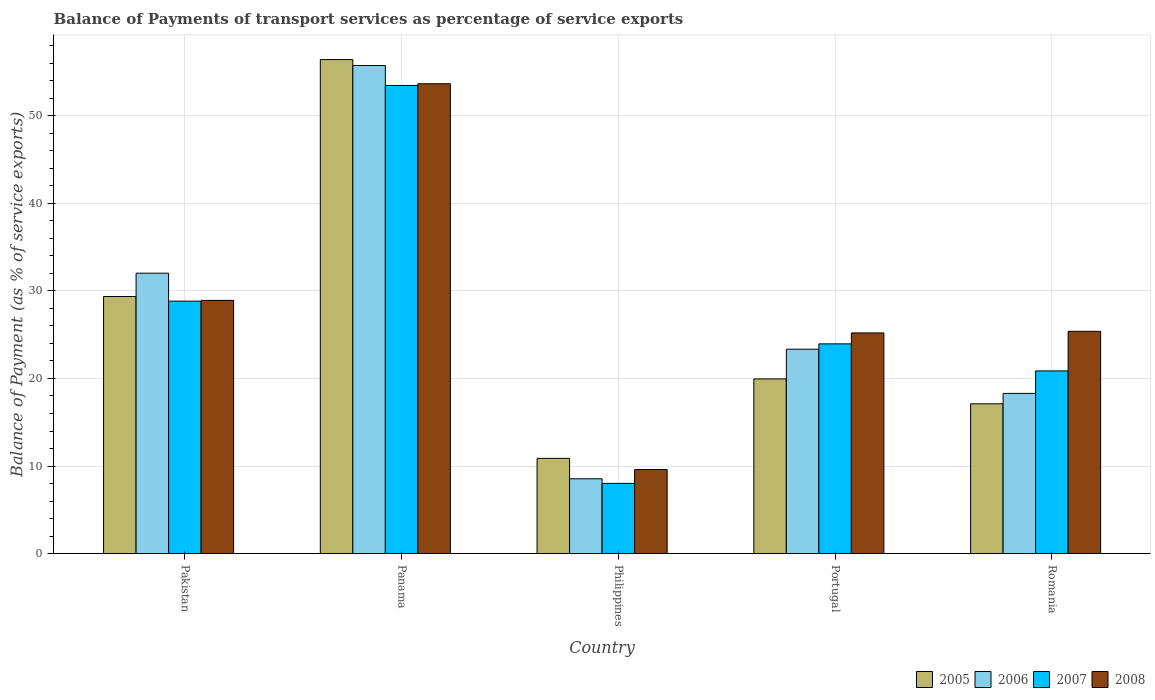How many different coloured bars are there?
Your answer should be very brief. 4. How many groups of bars are there?
Offer a very short reply. 5. Are the number of bars per tick equal to the number of legend labels?
Offer a terse response. Yes. Are the number of bars on each tick of the X-axis equal?
Make the answer very short. Yes. How many bars are there on the 3rd tick from the right?
Ensure brevity in your answer.  4. What is the label of the 4th group of bars from the left?
Provide a short and direct response. Portugal. In how many cases, is the number of bars for a given country not equal to the number of legend labels?
Your answer should be compact. 0. What is the balance of payments of transport services in 2006 in Romania?
Offer a terse response. 18.3. Across all countries, what is the maximum balance of payments of transport services in 2005?
Provide a short and direct response. 56.41. Across all countries, what is the minimum balance of payments of transport services in 2005?
Provide a succinct answer. 10.88. In which country was the balance of payments of transport services in 2007 maximum?
Ensure brevity in your answer.  Panama. What is the total balance of payments of transport services in 2008 in the graph?
Provide a short and direct response. 142.75. What is the difference between the balance of payments of transport services in 2007 in Philippines and that in Portugal?
Make the answer very short. -15.93. What is the difference between the balance of payments of transport services in 2006 in Portugal and the balance of payments of transport services in 2007 in Philippines?
Your answer should be very brief. 15.32. What is the average balance of payments of transport services in 2006 per country?
Your answer should be very brief. 27.59. What is the difference between the balance of payments of transport services of/in 2006 and balance of payments of transport services of/in 2007 in Romania?
Give a very brief answer. -2.57. In how many countries, is the balance of payments of transport services in 2006 greater than 56 %?
Provide a short and direct response. 0. What is the ratio of the balance of payments of transport services in 2005 in Pakistan to that in Romania?
Keep it short and to the point. 1.72. Is the balance of payments of transport services in 2005 in Pakistan less than that in Philippines?
Your answer should be compact. No. What is the difference between the highest and the second highest balance of payments of transport services in 2007?
Your response must be concise. -24.62. What is the difference between the highest and the lowest balance of payments of transport services in 2005?
Your response must be concise. 45.53. Is the sum of the balance of payments of transport services in 2005 in Pakistan and Philippines greater than the maximum balance of payments of transport services in 2007 across all countries?
Give a very brief answer. No. What does the 2nd bar from the left in Panama represents?
Keep it short and to the point. 2006. What does the 1st bar from the right in Philippines represents?
Provide a succinct answer. 2008. How many bars are there?
Make the answer very short. 20. How many countries are there in the graph?
Keep it short and to the point. 5. What is the difference between two consecutive major ticks on the Y-axis?
Your answer should be compact. 10. Are the values on the major ticks of Y-axis written in scientific E-notation?
Provide a short and direct response. No. Does the graph contain any zero values?
Give a very brief answer. No. Does the graph contain grids?
Give a very brief answer. Yes. How are the legend labels stacked?
Your answer should be compact. Horizontal. What is the title of the graph?
Offer a terse response. Balance of Payments of transport services as percentage of service exports. Does "1973" appear as one of the legend labels in the graph?
Your answer should be very brief. No. What is the label or title of the X-axis?
Provide a short and direct response. Country. What is the label or title of the Y-axis?
Provide a succinct answer. Balance of Payment (as % of service exports). What is the Balance of Payment (as % of service exports) of 2005 in Pakistan?
Make the answer very short. 29.36. What is the Balance of Payment (as % of service exports) of 2006 in Pakistan?
Your answer should be compact. 32.02. What is the Balance of Payment (as % of service exports) of 2007 in Pakistan?
Make the answer very short. 28.83. What is the Balance of Payment (as % of service exports) in 2008 in Pakistan?
Your answer should be very brief. 28.91. What is the Balance of Payment (as % of service exports) of 2005 in Panama?
Provide a succinct answer. 56.41. What is the Balance of Payment (as % of service exports) of 2006 in Panama?
Give a very brief answer. 55.73. What is the Balance of Payment (as % of service exports) in 2007 in Panama?
Ensure brevity in your answer.  53.45. What is the Balance of Payment (as % of service exports) of 2008 in Panama?
Provide a short and direct response. 53.65. What is the Balance of Payment (as % of service exports) of 2005 in Philippines?
Make the answer very short. 10.88. What is the Balance of Payment (as % of service exports) in 2006 in Philippines?
Keep it short and to the point. 8.55. What is the Balance of Payment (as % of service exports) in 2007 in Philippines?
Provide a short and direct response. 8.02. What is the Balance of Payment (as % of service exports) in 2008 in Philippines?
Ensure brevity in your answer.  9.61. What is the Balance of Payment (as % of service exports) in 2005 in Portugal?
Make the answer very short. 19.95. What is the Balance of Payment (as % of service exports) in 2006 in Portugal?
Ensure brevity in your answer.  23.34. What is the Balance of Payment (as % of service exports) of 2007 in Portugal?
Give a very brief answer. 23.95. What is the Balance of Payment (as % of service exports) of 2008 in Portugal?
Give a very brief answer. 25.2. What is the Balance of Payment (as % of service exports) in 2005 in Romania?
Your answer should be very brief. 17.11. What is the Balance of Payment (as % of service exports) in 2006 in Romania?
Offer a very short reply. 18.3. What is the Balance of Payment (as % of service exports) of 2007 in Romania?
Provide a succinct answer. 20.86. What is the Balance of Payment (as % of service exports) of 2008 in Romania?
Your response must be concise. 25.38. Across all countries, what is the maximum Balance of Payment (as % of service exports) of 2005?
Provide a succinct answer. 56.41. Across all countries, what is the maximum Balance of Payment (as % of service exports) in 2006?
Offer a terse response. 55.73. Across all countries, what is the maximum Balance of Payment (as % of service exports) in 2007?
Your answer should be very brief. 53.45. Across all countries, what is the maximum Balance of Payment (as % of service exports) in 2008?
Keep it short and to the point. 53.65. Across all countries, what is the minimum Balance of Payment (as % of service exports) in 2005?
Provide a succinct answer. 10.88. Across all countries, what is the minimum Balance of Payment (as % of service exports) of 2006?
Offer a terse response. 8.55. Across all countries, what is the minimum Balance of Payment (as % of service exports) in 2007?
Offer a terse response. 8.02. Across all countries, what is the minimum Balance of Payment (as % of service exports) in 2008?
Your response must be concise. 9.61. What is the total Balance of Payment (as % of service exports) in 2005 in the graph?
Keep it short and to the point. 133.7. What is the total Balance of Payment (as % of service exports) in 2006 in the graph?
Provide a short and direct response. 137.94. What is the total Balance of Payment (as % of service exports) in 2007 in the graph?
Offer a terse response. 135.12. What is the total Balance of Payment (as % of service exports) in 2008 in the graph?
Your answer should be compact. 142.75. What is the difference between the Balance of Payment (as % of service exports) in 2005 in Pakistan and that in Panama?
Your response must be concise. -27.05. What is the difference between the Balance of Payment (as % of service exports) of 2006 in Pakistan and that in Panama?
Provide a short and direct response. -23.71. What is the difference between the Balance of Payment (as % of service exports) in 2007 in Pakistan and that in Panama?
Your answer should be compact. -24.62. What is the difference between the Balance of Payment (as % of service exports) of 2008 in Pakistan and that in Panama?
Provide a short and direct response. -24.73. What is the difference between the Balance of Payment (as % of service exports) of 2005 in Pakistan and that in Philippines?
Keep it short and to the point. 18.48. What is the difference between the Balance of Payment (as % of service exports) of 2006 in Pakistan and that in Philippines?
Give a very brief answer. 23.47. What is the difference between the Balance of Payment (as % of service exports) of 2007 in Pakistan and that in Philippines?
Your response must be concise. 20.81. What is the difference between the Balance of Payment (as % of service exports) of 2008 in Pakistan and that in Philippines?
Your answer should be very brief. 19.31. What is the difference between the Balance of Payment (as % of service exports) of 2005 in Pakistan and that in Portugal?
Provide a succinct answer. 9.41. What is the difference between the Balance of Payment (as % of service exports) of 2006 in Pakistan and that in Portugal?
Your response must be concise. 8.68. What is the difference between the Balance of Payment (as % of service exports) in 2007 in Pakistan and that in Portugal?
Your answer should be very brief. 4.88. What is the difference between the Balance of Payment (as % of service exports) in 2008 in Pakistan and that in Portugal?
Keep it short and to the point. 3.71. What is the difference between the Balance of Payment (as % of service exports) in 2005 in Pakistan and that in Romania?
Provide a short and direct response. 12.25. What is the difference between the Balance of Payment (as % of service exports) of 2006 in Pakistan and that in Romania?
Provide a short and direct response. 13.72. What is the difference between the Balance of Payment (as % of service exports) of 2007 in Pakistan and that in Romania?
Your response must be concise. 7.97. What is the difference between the Balance of Payment (as % of service exports) in 2008 in Pakistan and that in Romania?
Give a very brief answer. 3.53. What is the difference between the Balance of Payment (as % of service exports) of 2005 in Panama and that in Philippines?
Offer a terse response. 45.53. What is the difference between the Balance of Payment (as % of service exports) in 2006 in Panama and that in Philippines?
Give a very brief answer. 47.19. What is the difference between the Balance of Payment (as % of service exports) of 2007 in Panama and that in Philippines?
Provide a short and direct response. 45.43. What is the difference between the Balance of Payment (as % of service exports) in 2008 in Panama and that in Philippines?
Offer a very short reply. 44.04. What is the difference between the Balance of Payment (as % of service exports) of 2005 in Panama and that in Portugal?
Provide a short and direct response. 36.46. What is the difference between the Balance of Payment (as % of service exports) in 2006 in Panama and that in Portugal?
Your response must be concise. 32.39. What is the difference between the Balance of Payment (as % of service exports) in 2007 in Panama and that in Portugal?
Your response must be concise. 29.5. What is the difference between the Balance of Payment (as % of service exports) in 2008 in Panama and that in Portugal?
Your answer should be very brief. 28.45. What is the difference between the Balance of Payment (as % of service exports) of 2005 in Panama and that in Romania?
Offer a terse response. 39.3. What is the difference between the Balance of Payment (as % of service exports) of 2006 in Panama and that in Romania?
Give a very brief answer. 37.44. What is the difference between the Balance of Payment (as % of service exports) in 2007 in Panama and that in Romania?
Offer a very short reply. 32.59. What is the difference between the Balance of Payment (as % of service exports) of 2008 in Panama and that in Romania?
Keep it short and to the point. 28.26. What is the difference between the Balance of Payment (as % of service exports) of 2005 in Philippines and that in Portugal?
Your answer should be very brief. -9.07. What is the difference between the Balance of Payment (as % of service exports) of 2006 in Philippines and that in Portugal?
Provide a succinct answer. -14.8. What is the difference between the Balance of Payment (as % of service exports) in 2007 in Philippines and that in Portugal?
Your answer should be very brief. -15.93. What is the difference between the Balance of Payment (as % of service exports) in 2008 in Philippines and that in Portugal?
Your answer should be very brief. -15.59. What is the difference between the Balance of Payment (as % of service exports) of 2005 in Philippines and that in Romania?
Give a very brief answer. -6.23. What is the difference between the Balance of Payment (as % of service exports) of 2006 in Philippines and that in Romania?
Give a very brief answer. -9.75. What is the difference between the Balance of Payment (as % of service exports) of 2007 in Philippines and that in Romania?
Give a very brief answer. -12.84. What is the difference between the Balance of Payment (as % of service exports) in 2008 in Philippines and that in Romania?
Offer a terse response. -15.77. What is the difference between the Balance of Payment (as % of service exports) of 2005 in Portugal and that in Romania?
Give a very brief answer. 2.84. What is the difference between the Balance of Payment (as % of service exports) of 2006 in Portugal and that in Romania?
Your answer should be very brief. 5.05. What is the difference between the Balance of Payment (as % of service exports) of 2007 in Portugal and that in Romania?
Provide a short and direct response. 3.09. What is the difference between the Balance of Payment (as % of service exports) in 2008 in Portugal and that in Romania?
Keep it short and to the point. -0.18. What is the difference between the Balance of Payment (as % of service exports) in 2005 in Pakistan and the Balance of Payment (as % of service exports) in 2006 in Panama?
Keep it short and to the point. -26.37. What is the difference between the Balance of Payment (as % of service exports) in 2005 in Pakistan and the Balance of Payment (as % of service exports) in 2007 in Panama?
Your answer should be very brief. -24.09. What is the difference between the Balance of Payment (as % of service exports) of 2005 in Pakistan and the Balance of Payment (as % of service exports) of 2008 in Panama?
Your answer should be very brief. -24.29. What is the difference between the Balance of Payment (as % of service exports) of 2006 in Pakistan and the Balance of Payment (as % of service exports) of 2007 in Panama?
Keep it short and to the point. -21.43. What is the difference between the Balance of Payment (as % of service exports) of 2006 in Pakistan and the Balance of Payment (as % of service exports) of 2008 in Panama?
Your answer should be very brief. -21.63. What is the difference between the Balance of Payment (as % of service exports) in 2007 in Pakistan and the Balance of Payment (as % of service exports) in 2008 in Panama?
Give a very brief answer. -24.82. What is the difference between the Balance of Payment (as % of service exports) of 2005 in Pakistan and the Balance of Payment (as % of service exports) of 2006 in Philippines?
Offer a very short reply. 20.81. What is the difference between the Balance of Payment (as % of service exports) of 2005 in Pakistan and the Balance of Payment (as % of service exports) of 2007 in Philippines?
Give a very brief answer. 21.33. What is the difference between the Balance of Payment (as % of service exports) in 2005 in Pakistan and the Balance of Payment (as % of service exports) in 2008 in Philippines?
Offer a very short reply. 19.75. What is the difference between the Balance of Payment (as % of service exports) in 2006 in Pakistan and the Balance of Payment (as % of service exports) in 2007 in Philippines?
Your answer should be very brief. 24. What is the difference between the Balance of Payment (as % of service exports) of 2006 in Pakistan and the Balance of Payment (as % of service exports) of 2008 in Philippines?
Your answer should be compact. 22.41. What is the difference between the Balance of Payment (as % of service exports) in 2007 in Pakistan and the Balance of Payment (as % of service exports) in 2008 in Philippines?
Ensure brevity in your answer.  19.22. What is the difference between the Balance of Payment (as % of service exports) of 2005 in Pakistan and the Balance of Payment (as % of service exports) of 2006 in Portugal?
Keep it short and to the point. 6.02. What is the difference between the Balance of Payment (as % of service exports) in 2005 in Pakistan and the Balance of Payment (as % of service exports) in 2007 in Portugal?
Provide a short and direct response. 5.41. What is the difference between the Balance of Payment (as % of service exports) of 2005 in Pakistan and the Balance of Payment (as % of service exports) of 2008 in Portugal?
Your response must be concise. 4.16. What is the difference between the Balance of Payment (as % of service exports) in 2006 in Pakistan and the Balance of Payment (as % of service exports) in 2007 in Portugal?
Ensure brevity in your answer.  8.07. What is the difference between the Balance of Payment (as % of service exports) in 2006 in Pakistan and the Balance of Payment (as % of service exports) in 2008 in Portugal?
Ensure brevity in your answer.  6.82. What is the difference between the Balance of Payment (as % of service exports) of 2007 in Pakistan and the Balance of Payment (as % of service exports) of 2008 in Portugal?
Provide a short and direct response. 3.63. What is the difference between the Balance of Payment (as % of service exports) in 2005 in Pakistan and the Balance of Payment (as % of service exports) in 2006 in Romania?
Make the answer very short. 11.06. What is the difference between the Balance of Payment (as % of service exports) in 2005 in Pakistan and the Balance of Payment (as % of service exports) in 2007 in Romania?
Make the answer very short. 8.5. What is the difference between the Balance of Payment (as % of service exports) of 2005 in Pakistan and the Balance of Payment (as % of service exports) of 2008 in Romania?
Your response must be concise. 3.98. What is the difference between the Balance of Payment (as % of service exports) of 2006 in Pakistan and the Balance of Payment (as % of service exports) of 2007 in Romania?
Provide a succinct answer. 11.16. What is the difference between the Balance of Payment (as % of service exports) of 2006 in Pakistan and the Balance of Payment (as % of service exports) of 2008 in Romania?
Ensure brevity in your answer.  6.64. What is the difference between the Balance of Payment (as % of service exports) of 2007 in Pakistan and the Balance of Payment (as % of service exports) of 2008 in Romania?
Give a very brief answer. 3.45. What is the difference between the Balance of Payment (as % of service exports) in 2005 in Panama and the Balance of Payment (as % of service exports) in 2006 in Philippines?
Offer a very short reply. 47.86. What is the difference between the Balance of Payment (as % of service exports) in 2005 in Panama and the Balance of Payment (as % of service exports) in 2007 in Philippines?
Provide a short and direct response. 48.38. What is the difference between the Balance of Payment (as % of service exports) of 2005 in Panama and the Balance of Payment (as % of service exports) of 2008 in Philippines?
Your response must be concise. 46.8. What is the difference between the Balance of Payment (as % of service exports) in 2006 in Panama and the Balance of Payment (as % of service exports) in 2007 in Philippines?
Keep it short and to the point. 47.71. What is the difference between the Balance of Payment (as % of service exports) of 2006 in Panama and the Balance of Payment (as % of service exports) of 2008 in Philippines?
Ensure brevity in your answer.  46.12. What is the difference between the Balance of Payment (as % of service exports) in 2007 in Panama and the Balance of Payment (as % of service exports) in 2008 in Philippines?
Provide a succinct answer. 43.84. What is the difference between the Balance of Payment (as % of service exports) of 2005 in Panama and the Balance of Payment (as % of service exports) of 2006 in Portugal?
Provide a short and direct response. 33.06. What is the difference between the Balance of Payment (as % of service exports) of 2005 in Panama and the Balance of Payment (as % of service exports) of 2007 in Portugal?
Offer a terse response. 32.46. What is the difference between the Balance of Payment (as % of service exports) in 2005 in Panama and the Balance of Payment (as % of service exports) in 2008 in Portugal?
Give a very brief answer. 31.21. What is the difference between the Balance of Payment (as % of service exports) of 2006 in Panama and the Balance of Payment (as % of service exports) of 2007 in Portugal?
Give a very brief answer. 31.78. What is the difference between the Balance of Payment (as % of service exports) in 2006 in Panama and the Balance of Payment (as % of service exports) in 2008 in Portugal?
Ensure brevity in your answer.  30.53. What is the difference between the Balance of Payment (as % of service exports) of 2007 in Panama and the Balance of Payment (as % of service exports) of 2008 in Portugal?
Offer a terse response. 28.25. What is the difference between the Balance of Payment (as % of service exports) in 2005 in Panama and the Balance of Payment (as % of service exports) in 2006 in Romania?
Provide a short and direct response. 38.11. What is the difference between the Balance of Payment (as % of service exports) in 2005 in Panama and the Balance of Payment (as % of service exports) in 2007 in Romania?
Offer a very short reply. 35.54. What is the difference between the Balance of Payment (as % of service exports) in 2005 in Panama and the Balance of Payment (as % of service exports) in 2008 in Romania?
Provide a short and direct response. 31.02. What is the difference between the Balance of Payment (as % of service exports) of 2006 in Panama and the Balance of Payment (as % of service exports) of 2007 in Romania?
Give a very brief answer. 34.87. What is the difference between the Balance of Payment (as % of service exports) in 2006 in Panama and the Balance of Payment (as % of service exports) in 2008 in Romania?
Ensure brevity in your answer.  30.35. What is the difference between the Balance of Payment (as % of service exports) in 2007 in Panama and the Balance of Payment (as % of service exports) in 2008 in Romania?
Ensure brevity in your answer.  28.07. What is the difference between the Balance of Payment (as % of service exports) in 2005 in Philippines and the Balance of Payment (as % of service exports) in 2006 in Portugal?
Your answer should be compact. -12.46. What is the difference between the Balance of Payment (as % of service exports) of 2005 in Philippines and the Balance of Payment (as % of service exports) of 2007 in Portugal?
Offer a very short reply. -13.07. What is the difference between the Balance of Payment (as % of service exports) of 2005 in Philippines and the Balance of Payment (as % of service exports) of 2008 in Portugal?
Keep it short and to the point. -14.32. What is the difference between the Balance of Payment (as % of service exports) in 2006 in Philippines and the Balance of Payment (as % of service exports) in 2007 in Portugal?
Your answer should be very brief. -15.4. What is the difference between the Balance of Payment (as % of service exports) in 2006 in Philippines and the Balance of Payment (as % of service exports) in 2008 in Portugal?
Your response must be concise. -16.65. What is the difference between the Balance of Payment (as % of service exports) of 2007 in Philippines and the Balance of Payment (as % of service exports) of 2008 in Portugal?
Make the answer very short. -17.18. What is the difference between the Balance of Payment (as % of service exports) in 2005 in Philippines and the Balance of Payment (as % of service exports) in 2006 in Romania?
Ensure brevity in your answer.  -7.42. What is the difference between the Balance of Payment (as % of service exports) of 2005 in Philippines and the Balance of Payment (as % of service exports) of 2007 in Romania?
Keep it short and to the point. -9.98. What is the difference between the Balance of Payment (as % of service exports) in 2005 in Philippines and the Balance of Payment (as % of service exports) in 2008 in Romania?
Offer a terse response. -14.5. What is the difference between the Balance of Payment (as % of service exports) in 2006 in Philippines and the Balance of Payment (as % of service exports) in 2007 in Romania?
Offer a terse response. -12.32. What is the difference between the Balance of Payment (as % of service exports) of 2006 in Philippines and the Balance of Payment (as % of service exports) of 2008 in Romania?
Provide a short and direct response. -16.84. What is the difference between the Balance of Payment (as % of service exports) of 2007 in Philippines and the Balance of Payment (as % of service exports) of 2008 in Romania?
Your response must be concise. -17.36. What is the difference between the Balance of Payment (as % of service exports) of 2005 in Portugal and the Balance of Payment (as % of service exports) of 2006 in Romania?
Keep it short and to the point. 1.65. What is the difference between the Balance of Payment (as % of service exports) in 2005 in Portugal and the Balance of Payment (as % of service exports) in 2007 in Romania?
Make the answer very short. -0.91. What is the difference between the Balance of Payment (as % of service exports) in 2005 in Portugal and the Balance of Payment (as % of service exports) in 2008 in Romania?
Your response must be concise. -5.43. What is the difference between the Balance of Payment (as % of service exports) in 2006 in Portugal and the Balance of Payment (as % of service exports) in 2007 in Romania?
Your answer should be very brief. 2.48. What is the difference between the Balance of Payment (as % of service exports) in 2006 in Portugal and the Balance of Payment (as % of service exports) in 2008 in Romania?
Keep it short and to the point. -2.04. What is the difference between the Balance of Payment (as % of service exports) in 2007 in Portugal and the Balance of Payment (as % of service exports) in 2008 in Romania?
Your answer should be compact. -1.43. What is the average Balance of Payment (as % of service exports) of 2005 per country?
Keep it short and to the point. 26.74. What is the average Balance of Payment (as % of service exports) in 2006 per country?
Ensure brevity in your answer.  27.59. What is the average Balance of Payment (as % of service exports) of 2007 per country?
Your answer should be very brief. 27.02. What is the average Balance of Payment (as % of service exports) of 2008 per country?
Offer a very short reply. 28.55. What is the difference between the Balance of Payment (as % of service exports) of 2005 and Balance of Payment (as % of service exports) of 2006 in Pakistan?
Make the answer very short. -2.66. What is the difference between the Balance of Payment (as % of service exports) of 2005 and Balance of Payment (as % of service exports) of 2007 in Pakistan?
Provide a succinct answer. 0.53. What is the difference between the Balance of Payment (as % of service exports) of 2005 and Balance of Payment (as % of service exports) of 2008 in Pakistan?
Give a very brief answer. 0.44. What is the difference between the Balance of Payment (as % of service exports) in 2006 and Balance of Payment (as % of service exports) in 2007 in Pakistan?
Your answer should be compact. 3.19. What is the difference between the Balance of Payment (as % of service exports) of 2006 and Balance of Payment (as % of service exports) of 2008 in Pakistan?
Give a very brief answer. 3.1. What is the difference between the Balance of Payment (as % of service exports) of 2007 and Balance of Payment (as % of service exports) of 2008 in Pakistan?
Offer a terse response. -0.08. What is the difference between the Balance of Payment (as % of service exports) in 2005 and Balance of Payment (as % of service exports) in 2006 in Panama?
Give a very brief answer. 0.67. What is the difference between the Balance of Payment (as % of service exports) of 2005 and Balance of Payment (as % of service exports) of 2007 in Panama?
Offer a terse response. 2.95. What is the difference between the Balance of Payment (as % of service exports) of 2005 and Balance of Payment (as % of service exports) of 2008 in Panama?
Provide a short and direct response. 2.76. What is the difference between the Balance of Payment (as % of service exports) in 2006 and Balance of Payment (as % of service exports) in 2007 in Panama?
Your answer should be very brief. 2.28. What is the difference between the Balance of Payment (as % of service exports) of 2006 and Balance of Payment (as % of service exports) of 2008 in Panama?
Provide a succinct answer. 2.09. What is the difference between the Balance of Payment (as % of service exports) in 2007 and Balance of Payment (as % of service exports) in 2008 in Panama?
Offer a very short reply. -0.19. What is the difference between the Balance of Payment (as % of service exports) of 2005 and Balance of Payment (as % of service exports) of 2006 in Philippines?
Your answer should be very brief. 2.33. What is the difference between the Balance of Payment (as % of service exports) in 2005 and Balance of Payment (as % of service exports) in 2007 in Philippines?
Keep it short and to the point. 2.86. What is the difference between the Balance of Payment (as % of service exports) of 2005 and Balance of Payment (as % of service exports) of 2008 in Philippines?
Keep it short and to the point. 1.27. What is the difference between the Balance of Payment (as % of service exports) in 2006 and Balance of Payment (as % of service exports) in 2007 in Philippines?
Ensure brevity in your answer.  0.52. What is the difference between the Balance of Payment (as % of service exports) of 2006 and Balance of Payment (as % of service exports) of 2008 in Philippines?
Your response must be concise. -1.06. What is the difference between the Balance of Payment (as % of service exports) of 2007 and Balance of Payment (as % of service exports) of 2008 in Philippines?
Your answer should be very brief. -1.58. What is the difference between the Balance of Payment (as % of service exports) in 2005 and Balance of Payment (as % of service exports) in 2006 in Portugal?
Offer a very short reply. -3.4. What is the difference between the Balance of Payment (as % of service exports) of 2005 and Balance of Payment (as % of service exports) of 2007 in Portugal?
Make the answer very short. -4. What is the difference between the Balance of Payment (as % of service exports) of 2005 and Balance of Payment (as % of service exports) of 2008 in Portugal?
Keep it short and to the point. -5.25. What is the difference between the Balance of Payment (as % of service exports) in 2006 and Balance of Payment (as % of service exports) in 2007 in Portugal?
Make the answer very short. -0.61. What is the difference between the Balance of Payment (as % of service exports) of 2006 and Balance of Payment (as % of service exports) of 2008 in Portugal?
Your answer should be compact. -1.86. What is the difference between the Balance of Payment (as % of service exports) of 2007 and Balance of Payment (as % of service exports) of 2008 in Portugal?
Offer a very short reply. -1.25. What is the difference between the Balance of Payment (as % of service exports) of 2005 and Balance of Payment (as % of service exports) of 2006 in Romania?
Offer a terse response. -1.19. What is the difference between the Balance of Payment (as % of service exports) in 2005 and Balance of Payment (as % of service exports) in 2007 in Romania?
Offer a terse response. -3.76. What is the difference between the Balance of Payment (as % of service exports) of 2005 and Balance of Payment (as % of service exports) of 2008 in Romania?
Offer a very short reply. -8.28. What is the difference between the Balance of Payment (as % of service exports) in 2006 and Balance of Payment (as % of service exports) in 2007 in Romania?
Your answer should be very brief. -2.57. What is the difference between the Balance of Payment (as % of service exports) in 2006 and Balance of Payment (as % of service exports) in 2008 in Romania?
Keep it short and to the point. -7.09. What is the difference between the Balance of Payment (as % of service exports) in 2007 and Balance of Payment (as % of service exports) in 2008 in Romania?
Your answer should be compact. -4.52. What is the ratio of the Balance of Payment (as % of service exports) of 2005 in Pakistan to that in Panama?
Offer a very short reply. 0.52. What is the ratio of the Balance of Payment (as % of service exports) of 2006 in Pakistan to that in Panama?
Provide a short and direct response. 0.57. What is the ratio of the Balance of Payment (as % of service exports) of 2007 in Pakistan to that in Panama?
Your answer should be very brief. 0.54. What is the ratio of the Balance of Payment (as % of service exports) of 2008 in Pakistan to that in Panama?
Provide a short and direct response. 0.54. What is the ratio of the Balance of Payment (as % of service exports) in 2005 in Pakistan to that in Philippines?
Provide a short and direct response. 2.7. What is the ratio of the Balance of Payment (as % of service exports) in 2006 in Pakistan to that in Philippines?
Your response must be concise. 3.75. What is the ratio of the Balance of Payment (as % of service exports) of 2007 in Pakistan to that in Philippines?
Provide a succinct answer. 3.59. What is the ratio of the Balance of Payment (as % of service exports) in 2008 in Pakistan to that in Philippines?
Your response must be concise. 3.01. What is the ratio of the Balance of Payment (as % of service exports) of 2005 in Pakistan to that in Portugal?
Your answer should be very brief. 1.47. What is the ratio of the Balance of Payment (as % of service exports) in 2006 in Pakistan to that in Portugal?
Give a very brief answer. 1.37. What is the ratio of the Balance of Payment (as % of service exports) of 2007 in Pakistan to that in Portugal?
Your answer should be compact. 1.2. What is the ratio of the Balance of Payment (as % of service exports) in 2008 in Pakistan to that in Portugal?
Keep it short and to the point. 1.15. What is the ratio of the Balance of Payment (as % of service exports) of 2005 in Pakistan to that in Romania?
Your answer should be very brief. 1.72. What is the ratio of the Balance of Payment (as % of service exports) of 2006 in Pakistan to that in Romania?
Offer a very short reply. 1.75. What is the ratio of the Balance of Payment (as % of service exports) in 2007 in Pakistan to that in Romania?
Offer a very short reply. 1.38. What is the ratio of the Balance of Payment (as % of service exports) in 2008 in Pakistan to that in Romania?
Offer a terse response. 1.14. What is the ratio of the Balance of Payment (as % of service exports) of 2005 in Panama to that in Philippines?
Offer a terse response. 5.18. What is the ratio of the Balance of Payment (as % of service exports) of 2006 in Panama to that in Philippines?
Provide a succinct answer. 6.52. What is the ratio of the Balance of Payment (as % of service exports) of 2007 in Panama to that in Philippines?
Give a very brief answer. 6.66. What is the ratio of the Balance of Payment (as % of service exports) of 2008 in Panama to that in Philippines?
Your answer should be compact. 5.58. What is the ratio of the Balance of Payment (as % of service exports) of 2005 in Panama to that in Portugal?
Ensure brevity in your answer.  2.83. What is the ratio of the Balance of Payment (as % of service exports) in 2006 in Panama to that in Portugal?
Provide a short and direct response. 2.39. What is the ratio of the Balance of Payment (as % of service exports) in 2007 in Panama to that in Portugal?
Provide a short and direct response. 2.23. What is the ratio of the Balance of Payment (as % of service exports) in 2008 in Panama to that in Portugal?
Your response must be concise. 2.13. What is the ratio of the Balance of Payment (as % of service exports) of 2005 in Panama to that in Romania?
Your response must be concise. 3.3. What is the ratio of the Balance of Payment (as % of service exports) of 2006 in Panama to that in Romania?
Make the answer very short. 3.05. What is the ratio of the Balance of Payment (as % of service exports) of 2007 in Panama to that in Romania?
Ensure brevity in your answer.  2.56. What is the ratio of the Balance of Payment (as % of service exports) in 2008 in Panama to that in Romania?
Your response must be concise. 2.11. What is the ratio of the Balance of Payment (as % of service exports) of 2005 in Philippines to that in Portugal?
Your response must be concise. 0.55. What is the ratio of the Balance of Payment (as % of service exports) in 2006 in Philippines to that in Portugal?
Offer a terse response. 0.37. What is the ratio of the Balance of Payment (as % of service exports) of 2007 in Philippines to that in Portugal?
Your answer should be very brief. 0.34. What is the ratio of the Balance of Payment (as % of service exports) in 2008 in Philippines to that in Portugal?
Your response must be concise. 0.38. What is the ratio of the Balance of Payment (as % of service exports) of 2005 in Philippines to that in Romania?
Offer a terse response. 0.64. What is the ratio of the Balance of Payment (as % of service exports) of 2006 in Philippines to that in Romania?
Offer a very short reply. 0.47. What is the ratio of the Balance of Payment (as % of service exports) of 2007 in Philippines to that in Romania?
Offer a very short reply. 0.38. What is the ratio of the Balance of Payment (as % of service exports) in 2008 in Philippines to that in Romania?
Your answer should be compact. 0.38. What is the ratio of the Balance of Payment (as % of service exports) of 2005 in Portugal to that in Romania?
Ensure brevity in your answer.  1.17. What is the ratio of the Balance of Payment (as % of service exports) in 2006 in Portugal to that in Romania?
Make the answer very short. 1.28. What is the ratio of the Balance of Payment (as % of service exports) of 2007 in Portugal to that in Romania?
Make the answer very short. 1.15. What is the difference between the highest and the second highest Balance of Payment (as % of service exports) in 2005?
Your answer should be very brief. 27.05. What is the difference between the highest and the second highest Balance of Payment (as % of service exports) in 2006?
Your answer should be compact. 23.71. What is the difference between the highest and the second highest Balance of Payment (as % of service exports) in 2007?
Offer a very short reply. 24.62. What is the difference between the highest and the second highest Balance of Payment (as % of service exports) of 2008?
Offer a terse response. 24.73. What is the difference between the highest and the lowest Balance of Payment (as % of service exports) of 2005?
Your response must be concise. 45.53. What is the difference between the highest and the lowest Balance of Payment (as % of service exports) in 2006?
Give a very brief answer. 47.19. What is the difference between the highest and the lowest Balance of Payment (as % of service exports) in 2007?
Offer a very short reply. 45.43. What is the difference between the highest and the lowest Balance of Payment (as % of service exports) in 2008?
Offer a terse response. 44.04. 